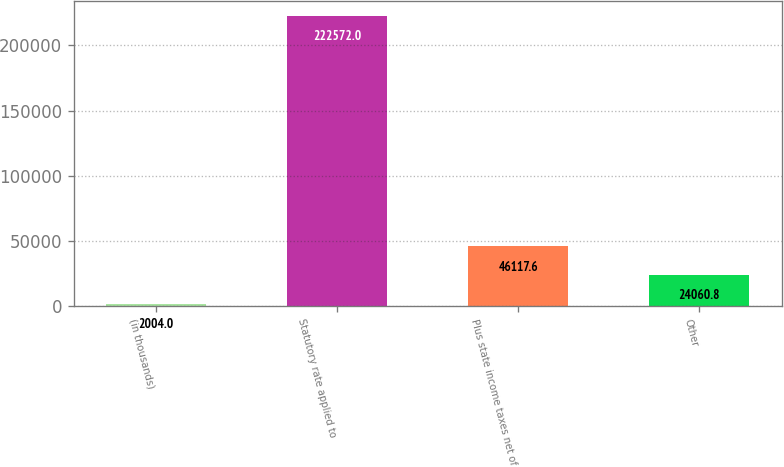Convert chart to OTSL. <chart><loc_0><loc_0><loc_500><loc_500><bar_chart><fcel>(in thousands)<fcel>Statutory rate applied to<fcel>Plus state income taxes net of<fcel>Other<nl><fcel>2004<fcel>222572<fcel>46117.6<fcel>24060.8<nl></chart> 